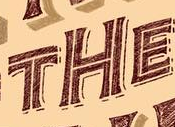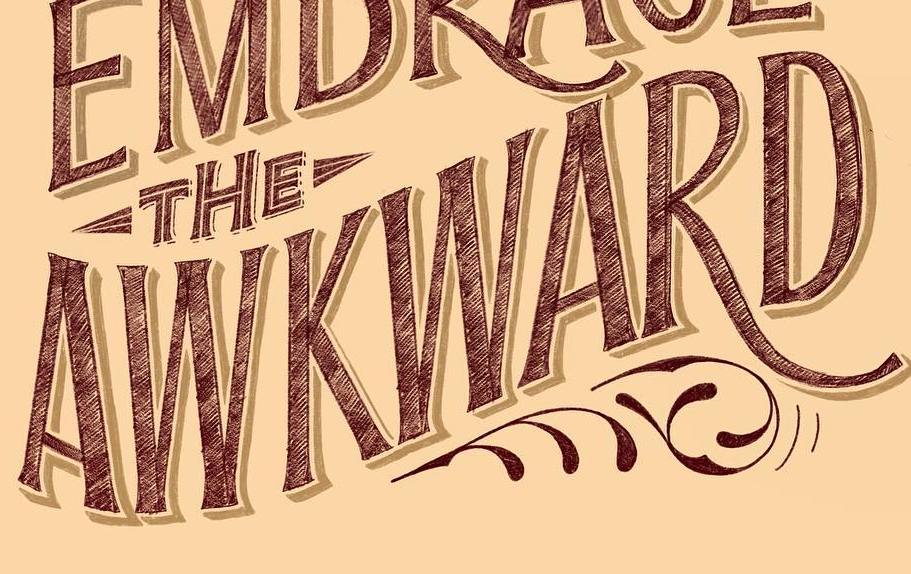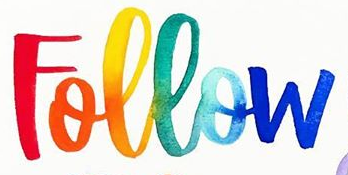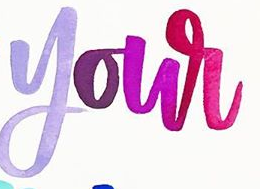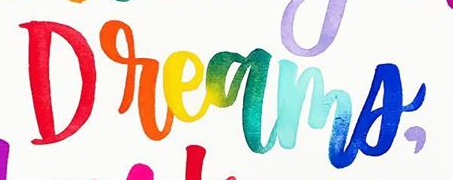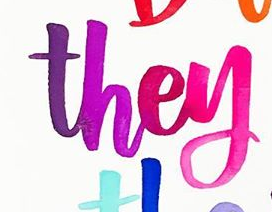Identify the words shown in these images in order, separated by a semicolon. THE; AWKWARD; Follow; your; Dreams,; they 